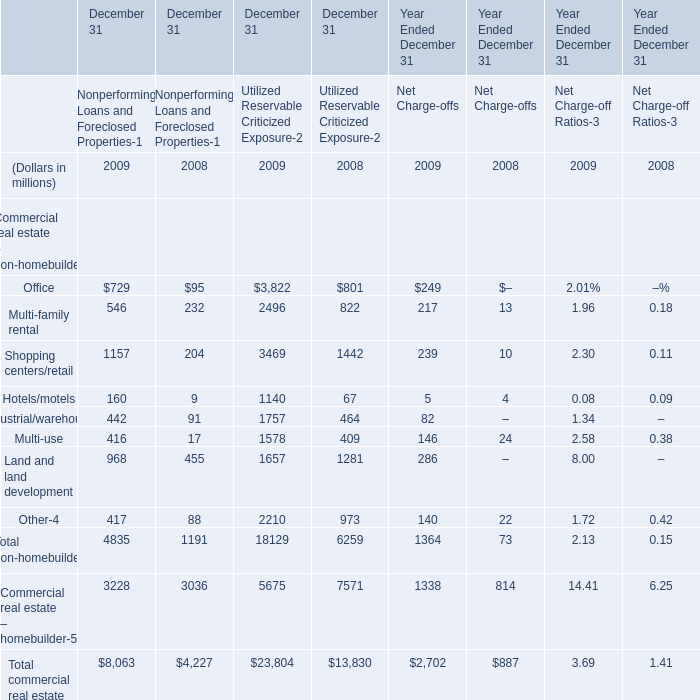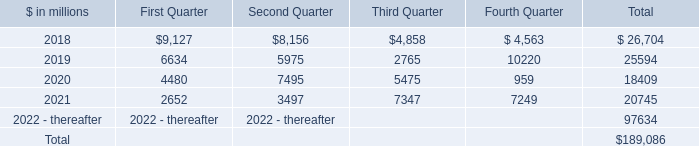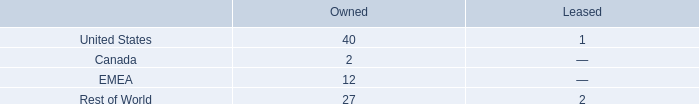what percent of owned facilities are in the us? 
Computations: (40 / 81)
Answer: 0.49383. Which year is Office for Nonperforming Loans and Foreclosed Propertiesthe highest? 
Answer: 2009. what is the portion of total number of facilities located in the rest of the world? 
Computations: ((27 + 2) / 84)
Answer: 0.34524. 